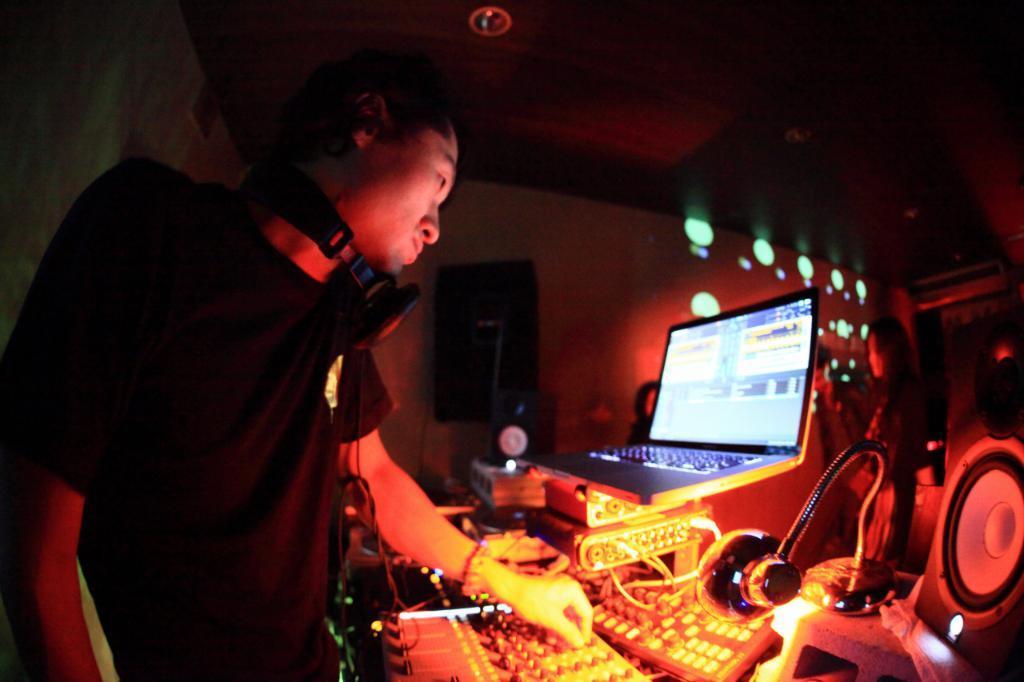In one or two sentences, can you explain what this image depicts? In this image there is a person standing, there are speakers, a laptop, lamp and some other items, and in the background there are group of people and lights. 